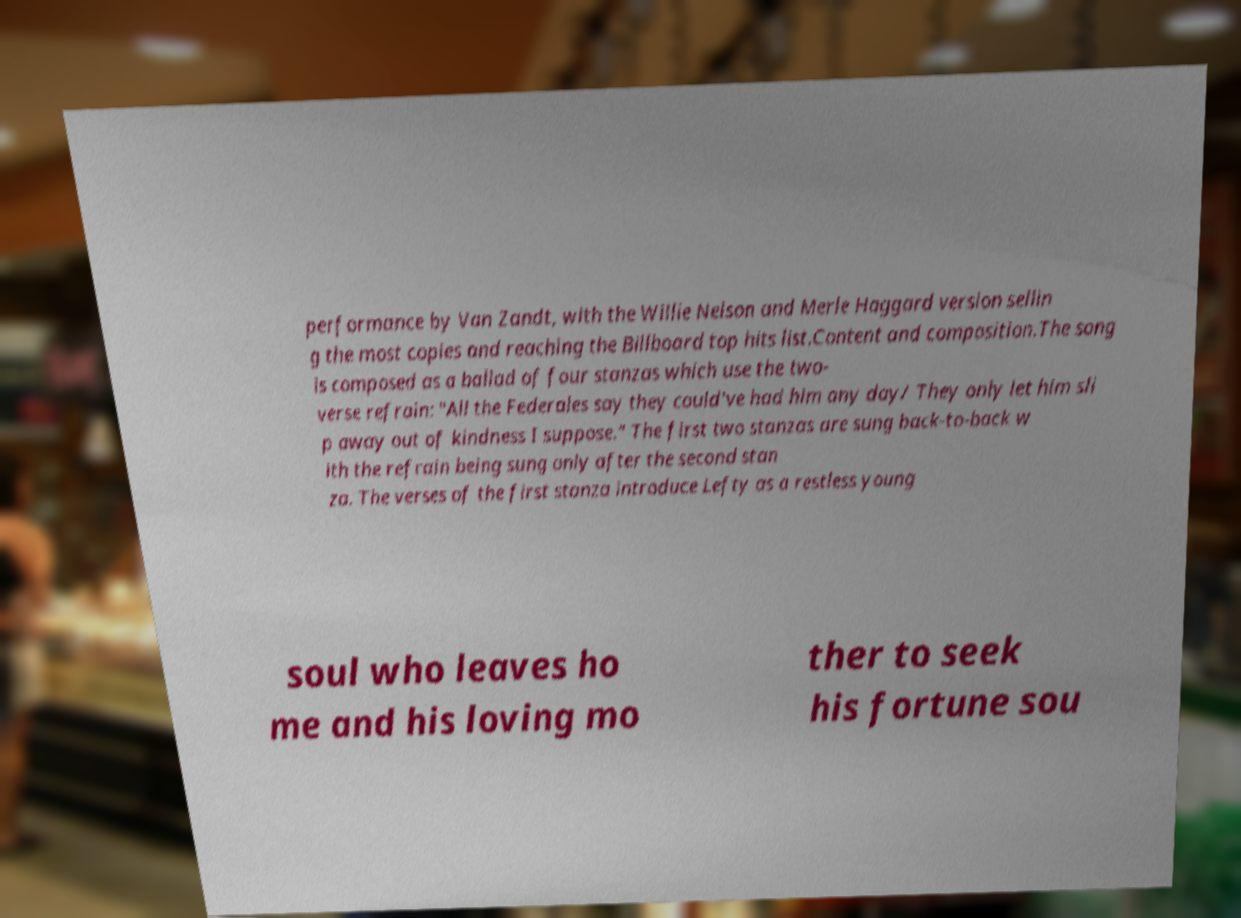Please identify and transcribe the text found in this image. performance by Van Zandt, with the Willie Nelson and Merle Haggard version sellin g the most copies and reaching the Billboard top hits list.Content and composition.The song is composed as a ballad of four stanzas which use the two- verse refrain: "All the Federales say they could've had him any day/ They only let him sli p away out of kindness I suppose." The first two stanzas are sung back-to-back w ith the refrain being sung only after the second stan za. The verses of the first stanza introduce Lefty as a restless young soul who leaves ho me and his loving mo ther to seek his fortune sou 